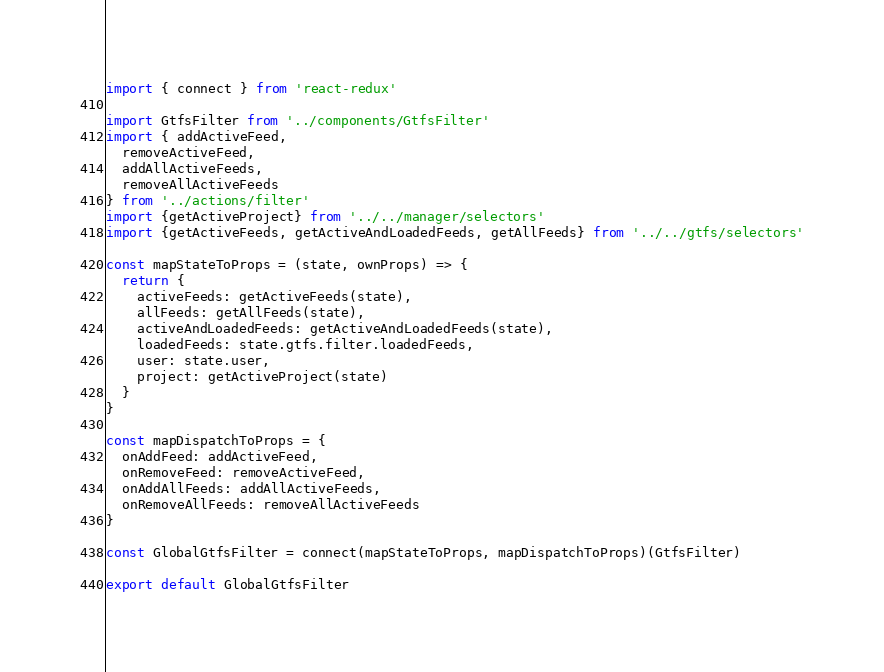<code> <loc_0><loc_0><loc_500><loc_500><_JavaScript_>import { connect } from 'react-redux'

import GtfsFilter from '../components/GtfsFilter'
import { addActiveFeed,
  removeActiveFeed,
  addAllActiveFeeds,
  removeAllActiveFeeds
} from '../actions/filter'
import {getActiveProject} from '../../manager/selectors'
import {getActiveFeeds, getActiveAndLoadedFeeds, getAllFeeds} from '../../gtfs/selectors'

const mapStateToProps = (state, ownProps) => {
  return {
    activeFeeds: getActiveFeeds(state),
    allFeeds: getAllFeeds(state),
    activeAndLoadedFeeds: getActiveAndLoadedFeeds(state),
    loadedFeeds: state.gtfs.filter.loadedFeeds,
    user: state.user,
    project: getActiveProject(state)
  }
}

const mapDispatchToProps = {
  onAddFeed: addActiveFeed,
  onRemoveFeed: removeActiveFeed,
  onAddAllFeeds: addAllActiveFeeds,
  onRemoveAllFeeds: removeAllActiveFeeds
}

const GlobalGtfsFilter = connect(mapStateToProps, mapDispatchToProps)(GtfsFilter)

export default GlobalGtfsFilter
</code> 